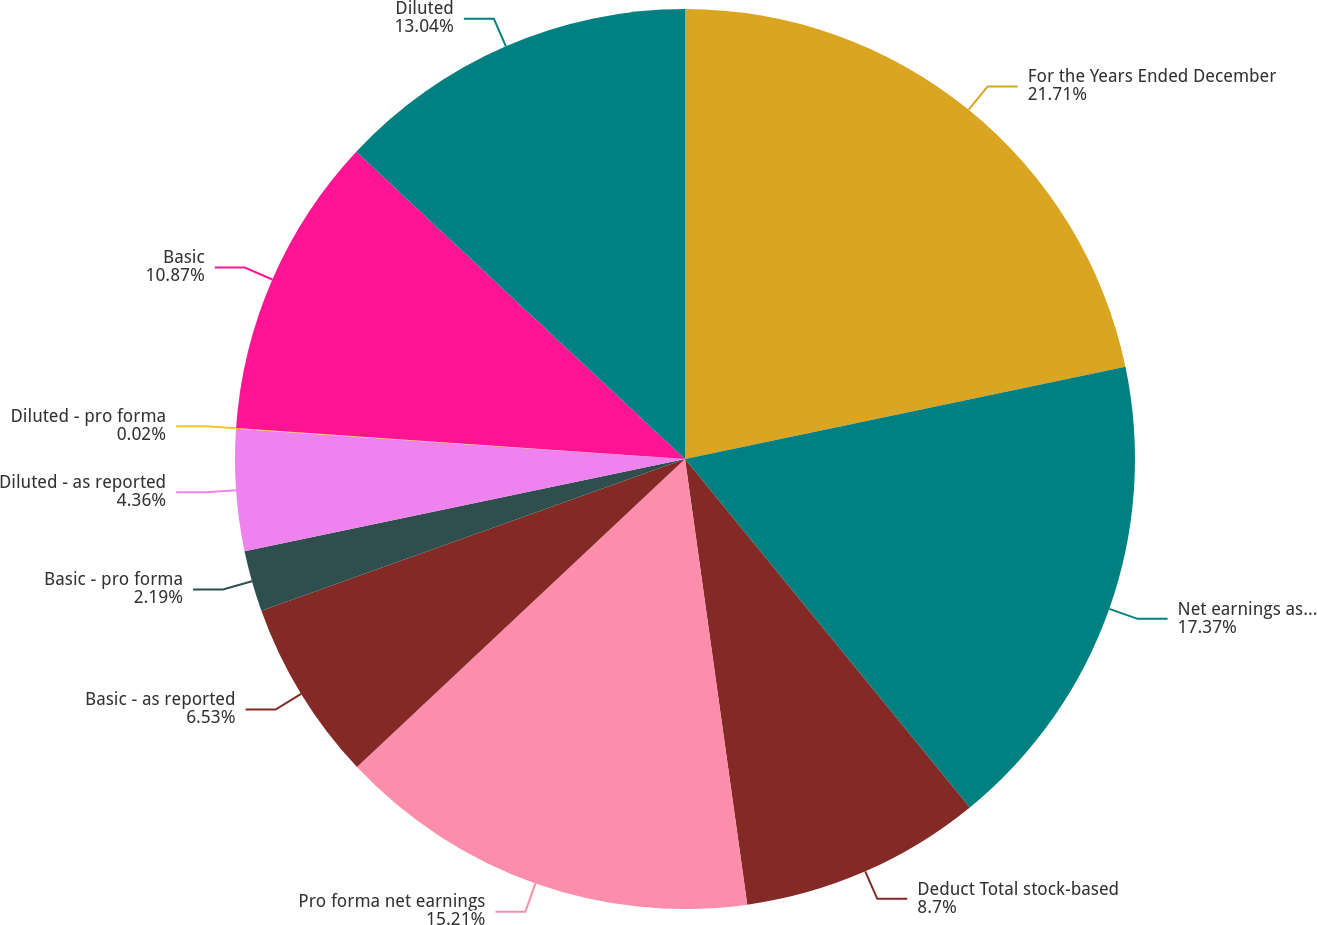Convert chart. <chart><loc_0><loc_0><loc_500><loc_500><pie_chart><fcel>For the Years Ended December<fcel>Net earnings as reported<fcel>Deduct Total stock-based<fcel>Pro forma net earnings<fcel>Basic - as reported<fcel>Basic - pro forma<fcel>Diluted - as reported<fcel>Diluted - pro forma<fcel>Basic<fcel>Diluted<nl><fcel>21.72%<fcel>17.38%<fcel>8.7%<fcel>15.21%<fcel>6.53%<fcel>2.19%<fcel>4.36%<fcel>0.02%<fcel>10.87%<fcel>13.04%<nl></chart> 